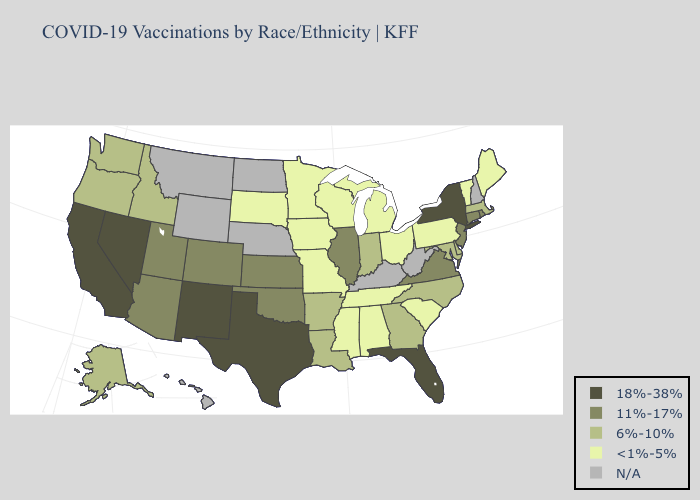Which states hav the highest value in the MidWest?
Keep it brief. Illinois, Kansas. Does New Jersey have the lowest value in the Northeast?
Short answer required. No. Name the states that have a value in the range N/A?
Write a very short answer. Hawaii, Kentucky, Montana, Nebraska, New Hampshire, North Dakota, West Virginia, Wyoming. What is the value of Illinois?
Write a very short answer. 11%-17%. Name the states that have a value in the range 18%-38%?
Quick response, please. California, Florida, Nevada, New Mexico, New York, Texas. What is the value of Nevada?
Give a very brief answer. 18%-38%. What is the lowest value in the USA?
Be succinct. <1%-5%. Does Idaho have the highest value in the West?
Concise answer only. No. Name the states that have a value in the range 18%-38%?
Keep it brief. California, Florida, Nevada, New Mexico, New York, Texas. Which states have the lowest value in the USA?
Keep it brief. Alabama, Iowa, Maine, Michigan, Minnesota, Mississippi, Missouri, Ohio, Pennsylvania, South Carolina, South Dakota, Tennessee, Vermont, Wisconsin. Name the states that have a value in the range 6%-10%?
Quick response, please. Alaska, Arkansas, Delaware, Georgia, Idaho, Indiana, Louisiana, Maryland, Massachusetts, North Carolina, Oregon, Washington. What is the value of Georgia?
Be succinct. 6%-10%. What is the highest value in the USA?
Keep it brief. 18%-38%. Does the first symbol in the legend represent the smallest category?
Concise answer only. No. 